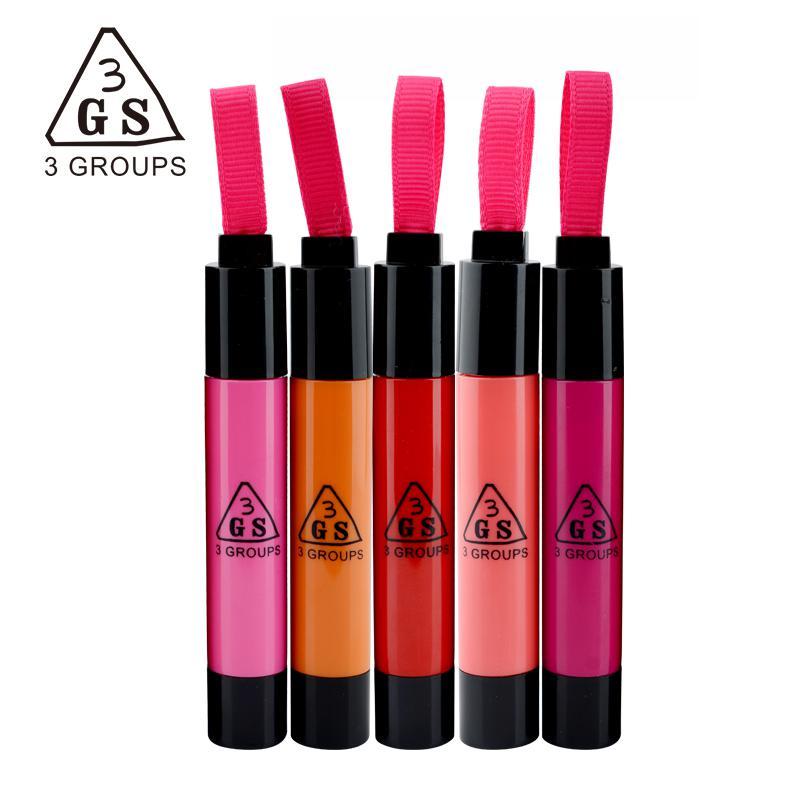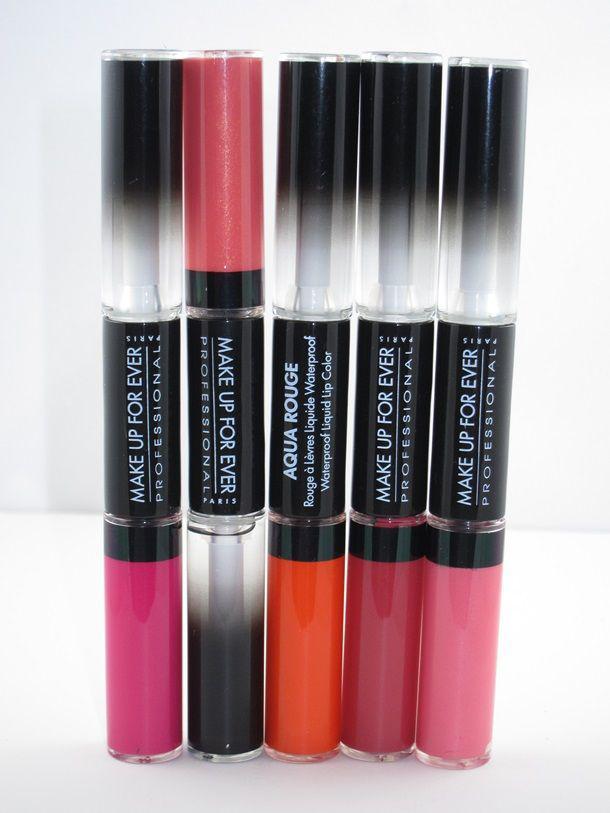The first image is the image on the left, the second image is the image on the right. For the images displayed, is the sentence "Right image shows two horizontal rows of the same product style." factually correct? Answer yes or no. No. The first image is the image on the left, the second image is the image on the right. For the images shown, is this caption "There are at least eleven lipsticks in the image on the left." true? Answer yes or no. No. 